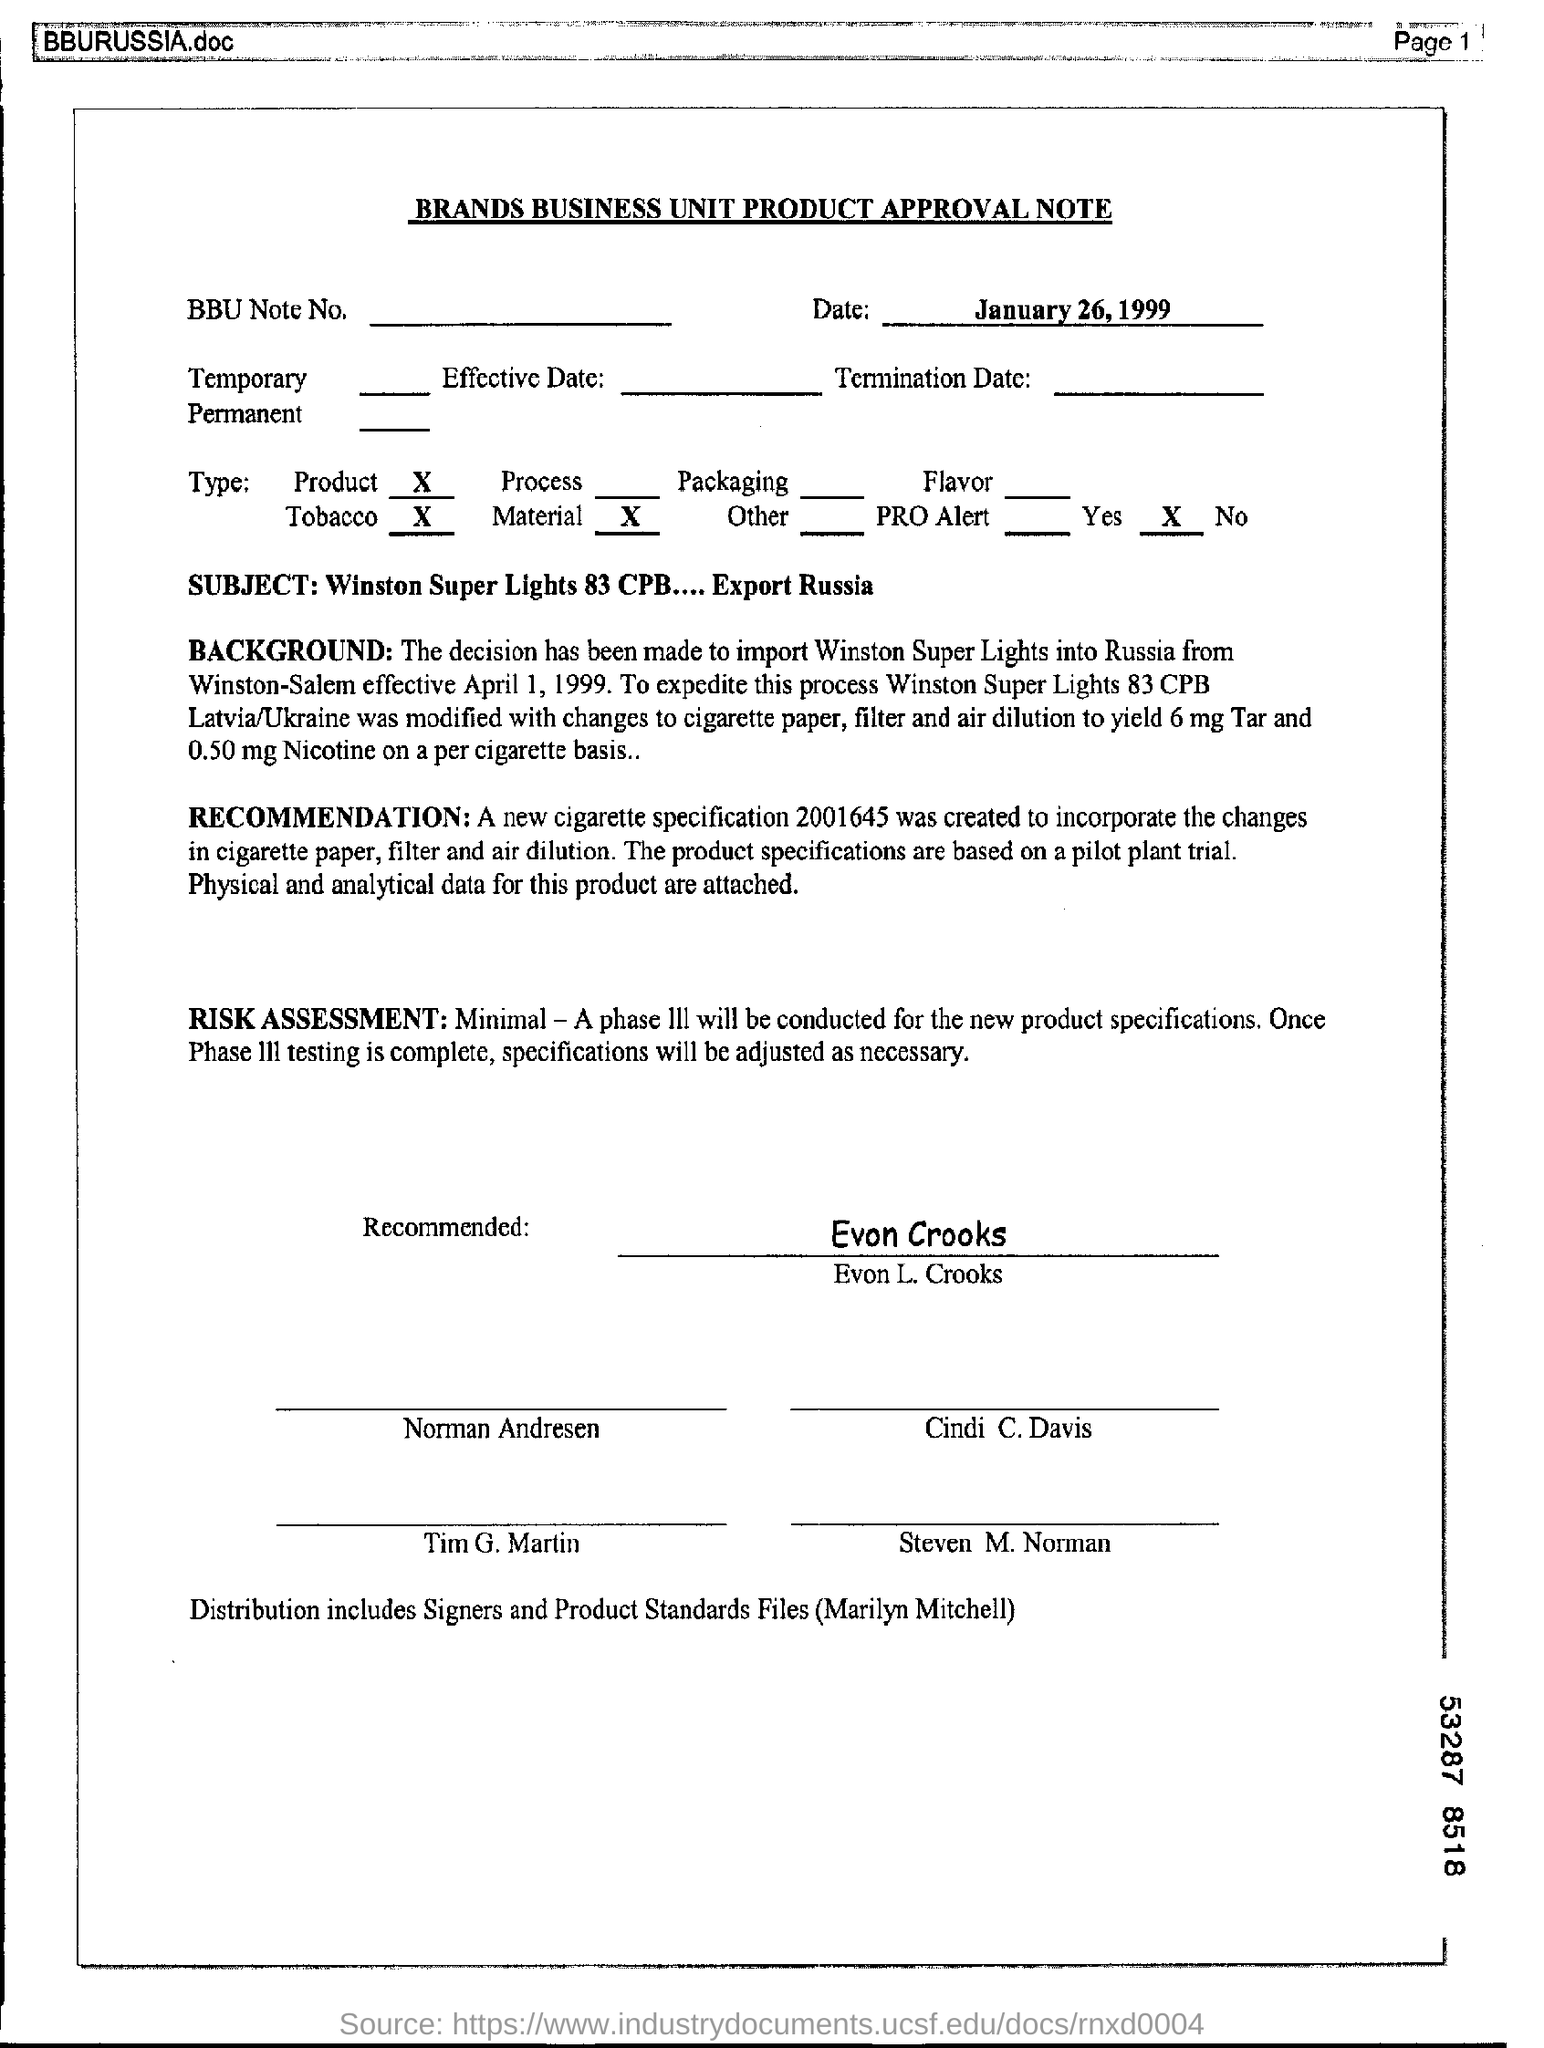Identify some key points in this picture. The cigarettes are being imported from Winston-Salem. The changes made in cigarettes include cigarette paper, filters, and air dilution. The brand name of the cigarette is Winston Super Lights. The Winston Super Lights are being imported to Russia. The Approval Note has been signed by Evon L. Crooks. 